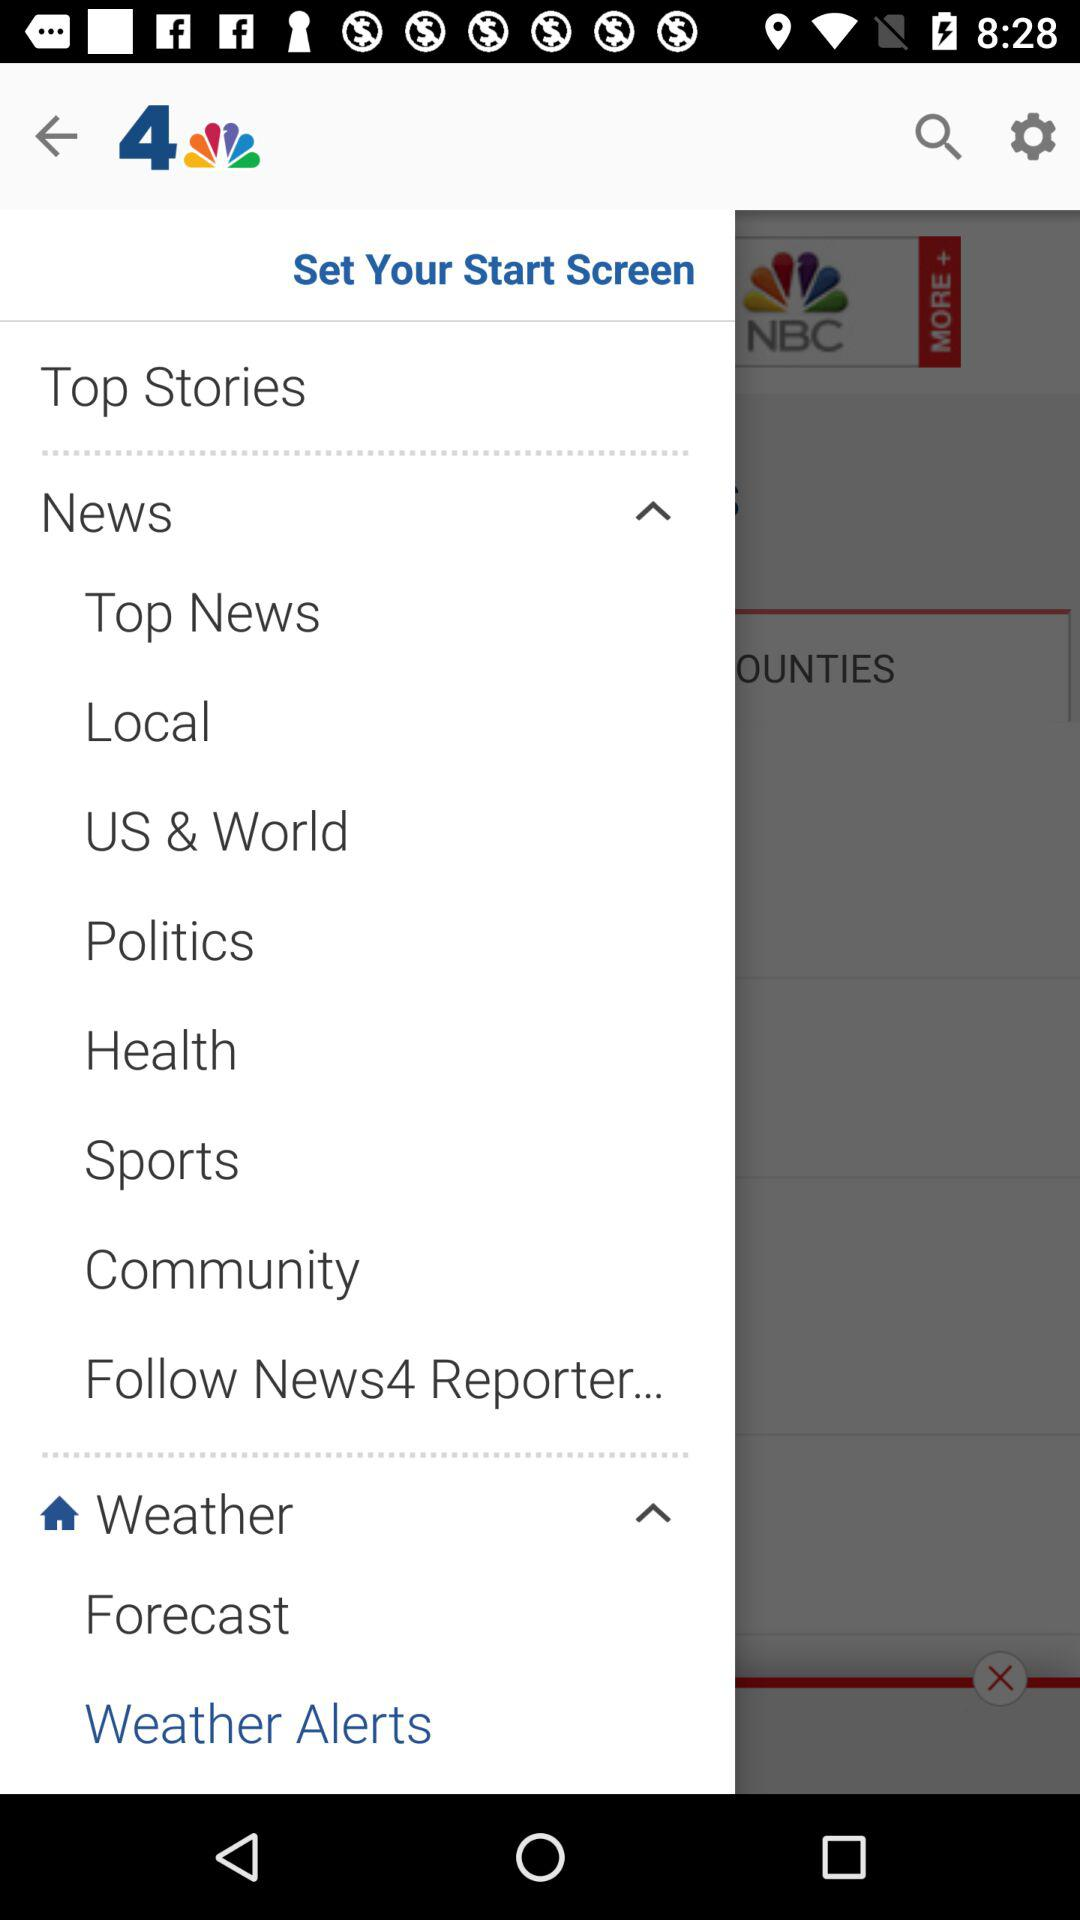What is the application name? The application name is "NBC LA: News, Weather". 